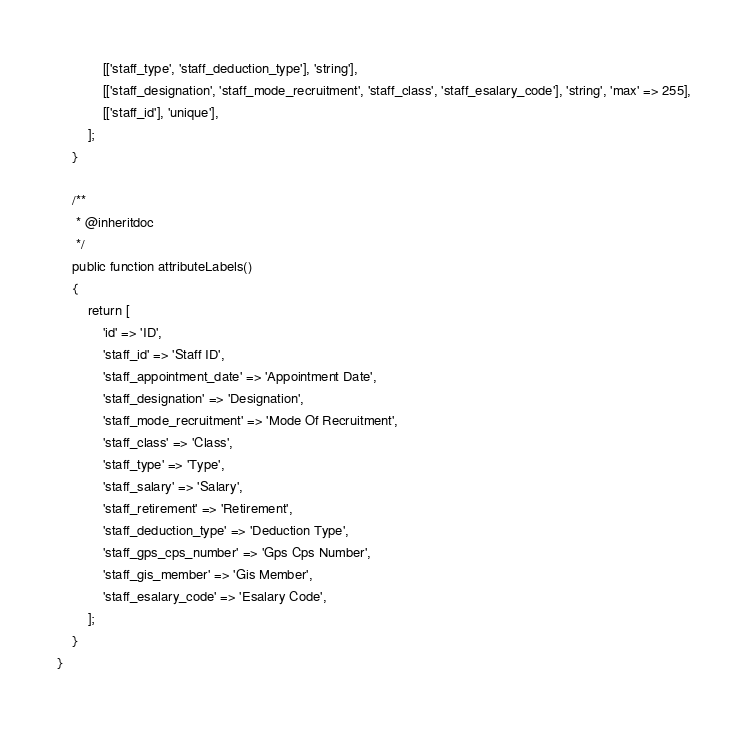Convert code to text. <code><loc_0><loc_0><loc_500><loc_500><_PHP_>            [['staff_type', 'staff_deduction_type'], 'string'],
            [['staff_designation', 'staff_mode_recruitment', 'staff_class', 'staff_esalary_code'], 'string', 'max' => 255],
            [['staff_id'], 'unique'],
        ];
    }

    /**
     * @inheritdoc
     */
    public function attributeLabels()
    {
        return [
            'id' => 'ID',
            'staff_id' => 'Staff ID',
            'staff_appointment_date' => 'Appointment Date',
            'staff_designation' => 'Designation',
            'staff_mode_recruitment' => 'Mode Of Recruitment',
            'staff_class' => 'Class',
            'staff_type' => 'Type',
            'staff_salary' => 'Salary',
            'staff_retirement' => 'Retirement',
            'staff_deduction_type' => 'Deduction Type',
            'staff_gps_cps_number' => 'Gps Cps Number',
            'staff_gis_member' => 'Gis Member',
            'staff_esalary_code' => 'Esalary Code',
        ];
    }
}
</code> 